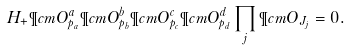<formula> <loc_0><loc_0><loc_500><loc_500>H _ { + } \P c m { O } _ { p _ { a } } ^ { a } \P c m { O } _ { p _ { b } } ^ { b } \P c m { O } _ { p _ { c } } ^ { c } \P c m { O } _ { p _ { d } } ^ { d } \prod _ { j } \P c m { O } _ { J _ { j } } = 0 .</formula> 